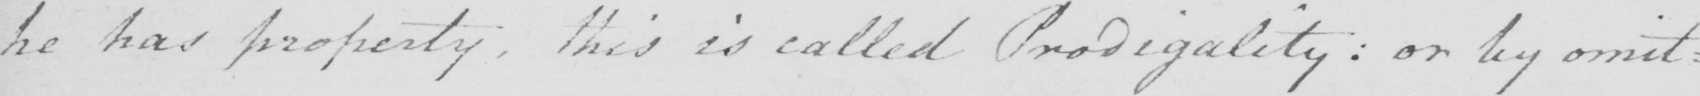Please transcribe the handwritten text in this image. he has property , this is called Prodigality :  or by omit : 